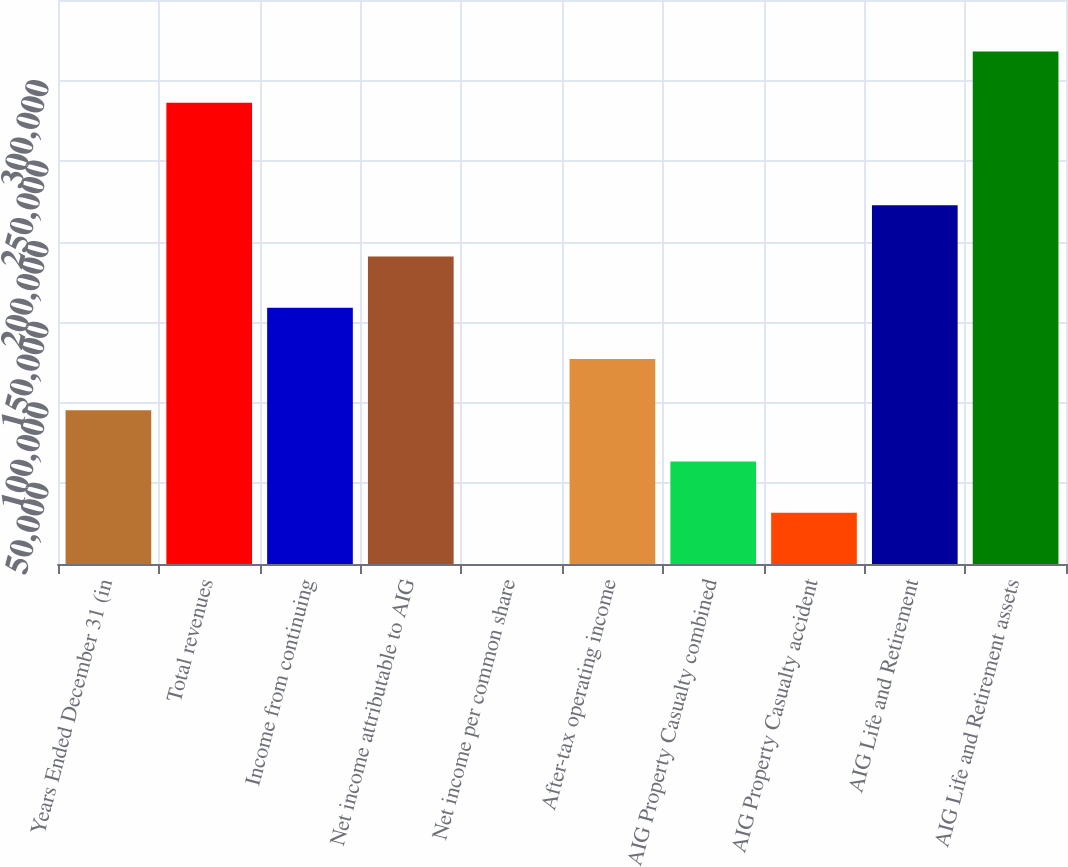Convert chart. <chart><loc_0><loc_0><loc_500><loc_500><bar_chart><fcel>Years Ended December 31 (in<fcel>Total revenues<fcel>Income from continuing<fcel>Net income attributable to AIG<fcel>Net income per common share<fcel>After-tax operating income<fcel>AIG Property Casualty combined<fcel>AIG Property Casualty accident<fcel>AIG Life and Retirement<fcel>AIG Life and Retirement assets<nl><fcel>95397.4<fcel>286180<fcel>158992<fcel>190789<fcel>6.13<fcel>127194<fcel>63600.3<fcel>31803.2<fcel>222586<fcel>317977<nl></chart> 